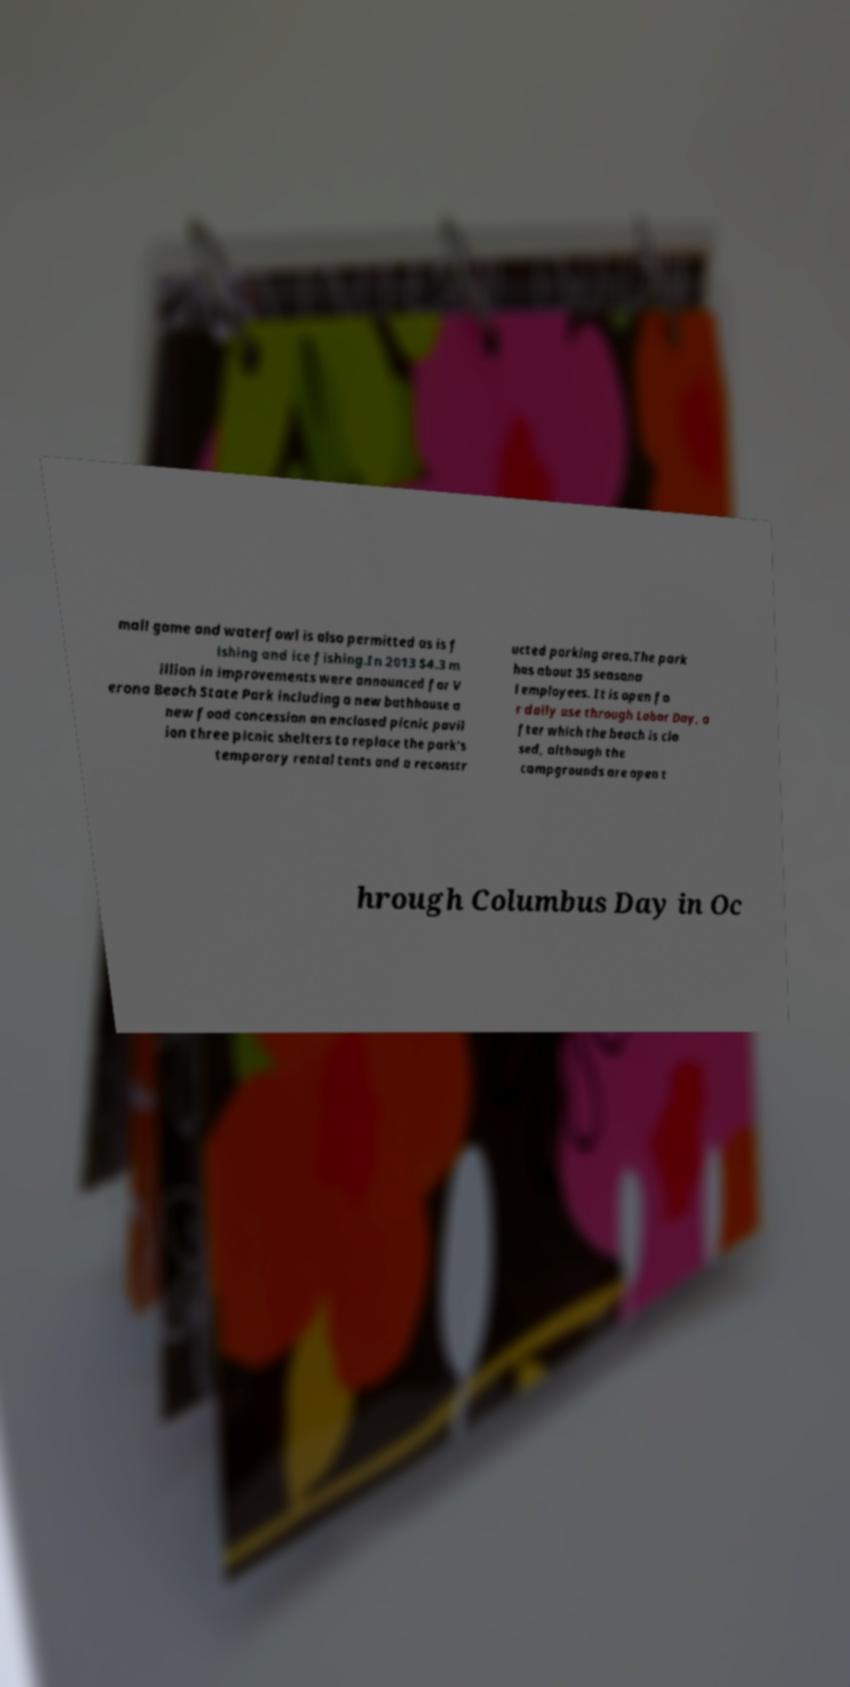Can you accurately transcribe the text from the provided image for me? mall game and waterfowl is also permitted as is f ishing and ice fishing.In 2013 $4.3 m illion in improvements were announced for V erona Beach State Park including a new bathhouse a new food concession an enclosed picnic pavil ion three picnic shelters to replace the park's temporary rental tents and a reconstr ucted parking area.The park has about 35 seasona l employees. It is open fo r daily use through Labor Day, a fter which the beach is clo sed, although the campgrounds are open t hrough Columbus Day in Oc 